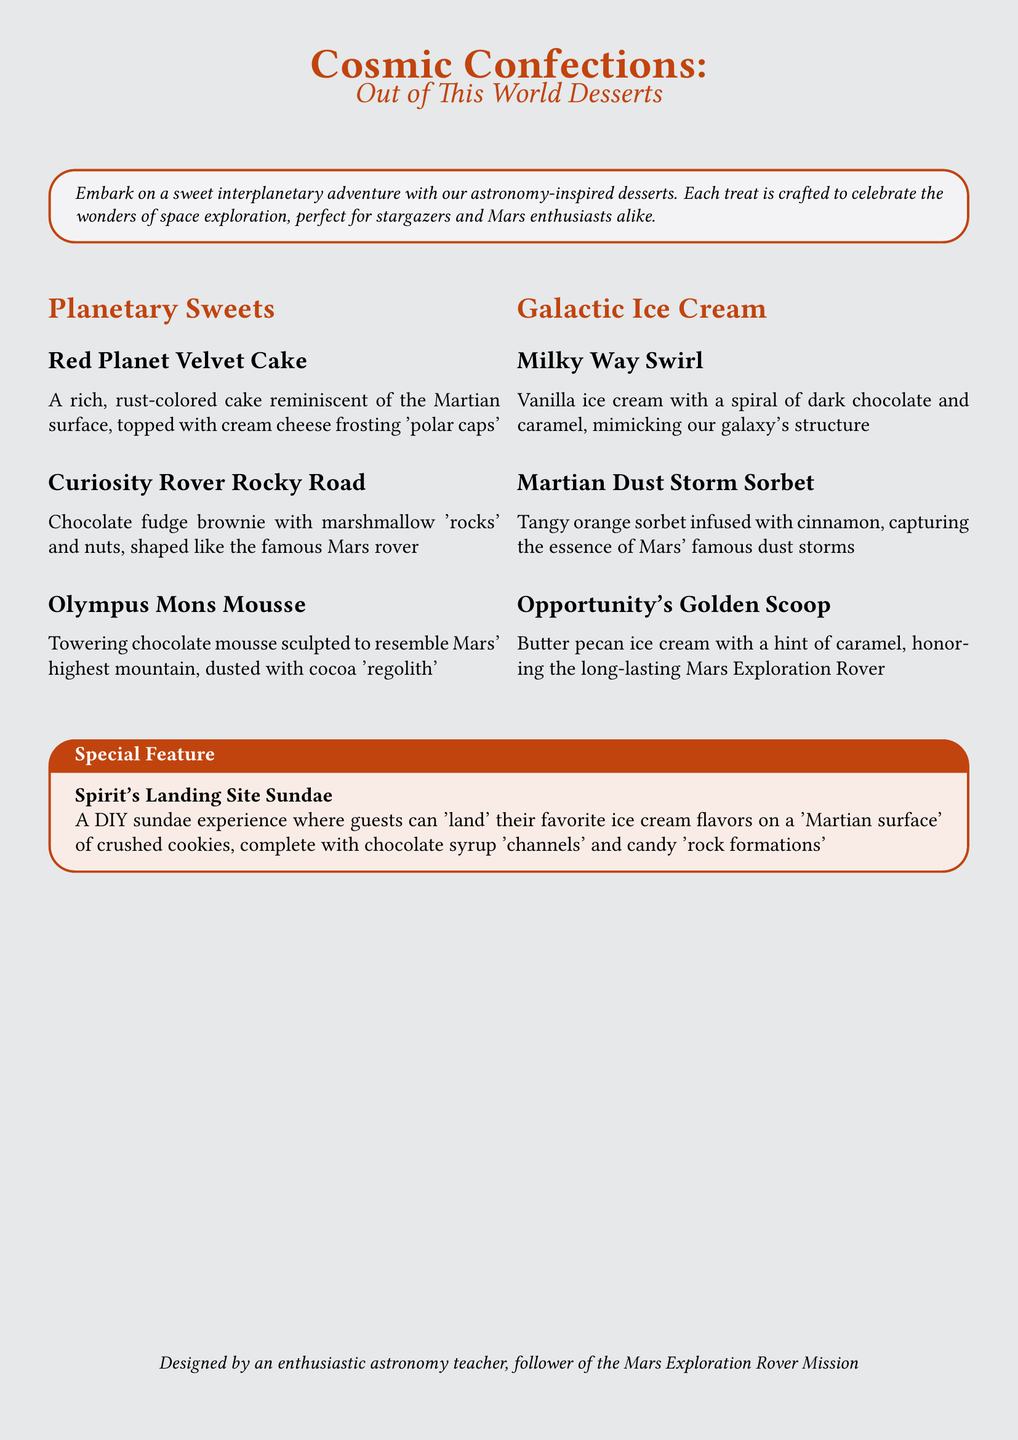what is the name of the cake inspired by Mars? The cake inspired by Mars is called "Red Planet Velvet Cake."
Answer: Red Planet Velvet Cake what unique feature does the "Spirit's Landing Site Sundae" offer? The "Spirit's Landing Site Sundae" offers a DIY sundae experience where guests can customize their desserts.
Answer: DIY sundae experience which ice cream flavor honors the Opportunity rover? The flavor that honors the Opportunity rover is called "Opportunity's Golden Scoop."
Answer: Opportunity's Golden Scoop how many ice cream flavors are listed in the menu? The menu lists a total of three ice cream flavors.
Answer: three what dessert is shaped like the famous Mars rover? The dessert shaped like the famous Mars rover is called "Curiosity Rover Rocky Road."
Answer: Curiosity Rover Rocky Road what color is the "Milky Way Swirl" ice cream? The "Milky Way Swirl" ice cream is vanilla with a spiral of dark chocolate and caramel.
Answer: vanilla what is the main ingredient of "Martian Dust Storm Sorbet"? The main ingredient of "Martian Dust Storm Sorbet" is tangy orange.
Answer: tangy orange what type of dessert is "Olympus Mons Mousse"? "Olympus Mons Mousse" is a chocolate mousse.
Answer: chocolate mousse what does the "Curiosity Rover Rocky Road" dessert include? The "Curiosity Rover Rocky Road" dessert includes chocolate fudge brownie, marshmallows, and nuts.
Answer: chocolate fudge brownie with marshmallow 'rocks' and nuts 